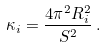Convert formula to latex. <formula><loc_0><loc_0><loc_500><loc_500>\kappa _ { i } = \frac { 4 \pi ^ { 2 } R _ { i } ^ { 2 } } { S ^ { 2 } } \, .</formula> 